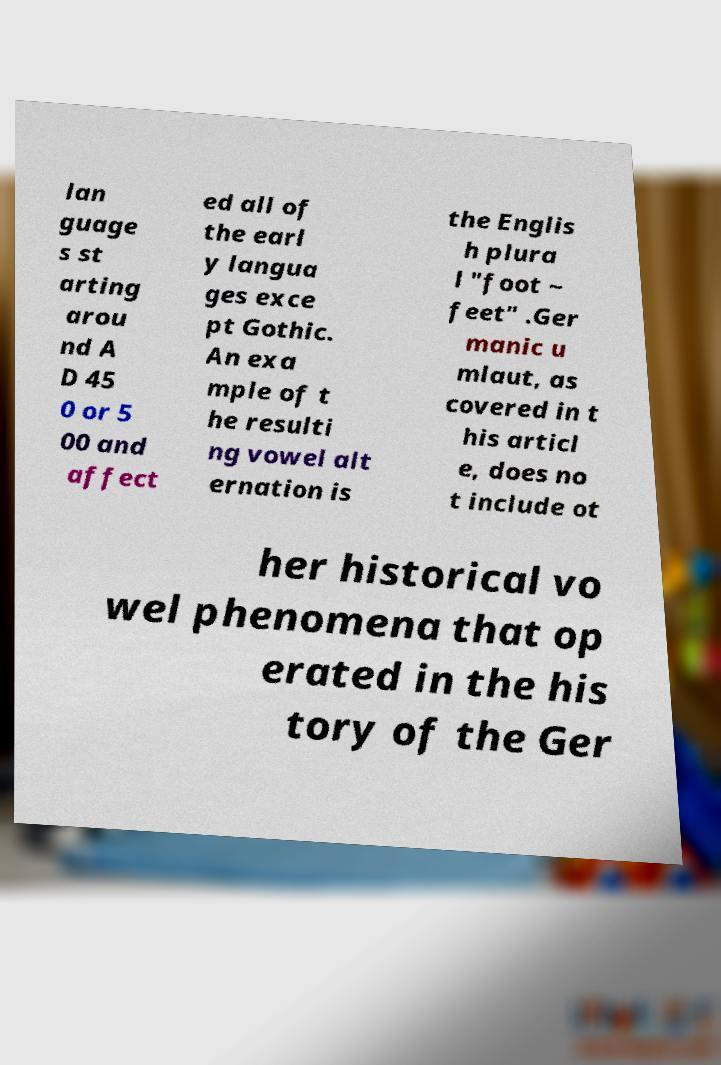Please read and relay the text visible in this image. What does it say? lan guage s st arting arou nd A D 45 0 or 5 00 and affect ed all of the earl y langua ges exce pt Gothic. An exa mple of t he resulti ng vowel alt ernation is the Englis h plura l "foot ~ feet" .Ger manic u mlaut, as covered in t his articl e, does no t include ot her historical vo wel phenomena that op erated in the his tory of the Ger 